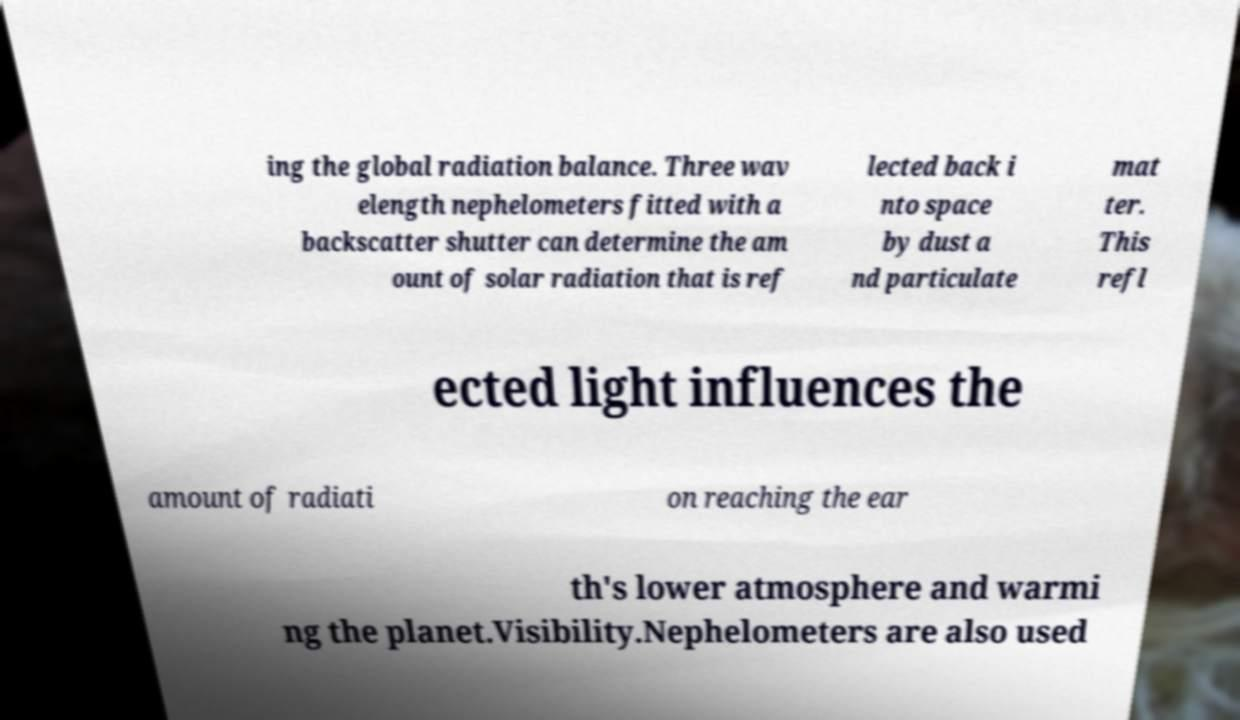Could you assist in decoding the text presented in this image and type it out clearly? ing the global radiation balance. Three wav elength nephelometers fitted with a backscatter shutter can determine the am ount of solar radiation that is ref lected back i nto space by dust a nd particulate mat ter. This refl ected light influences the amount of radiati on reaching the ear th's lower atmosphere and warmi ng the planet.Visibility.Nephelometers are also used 